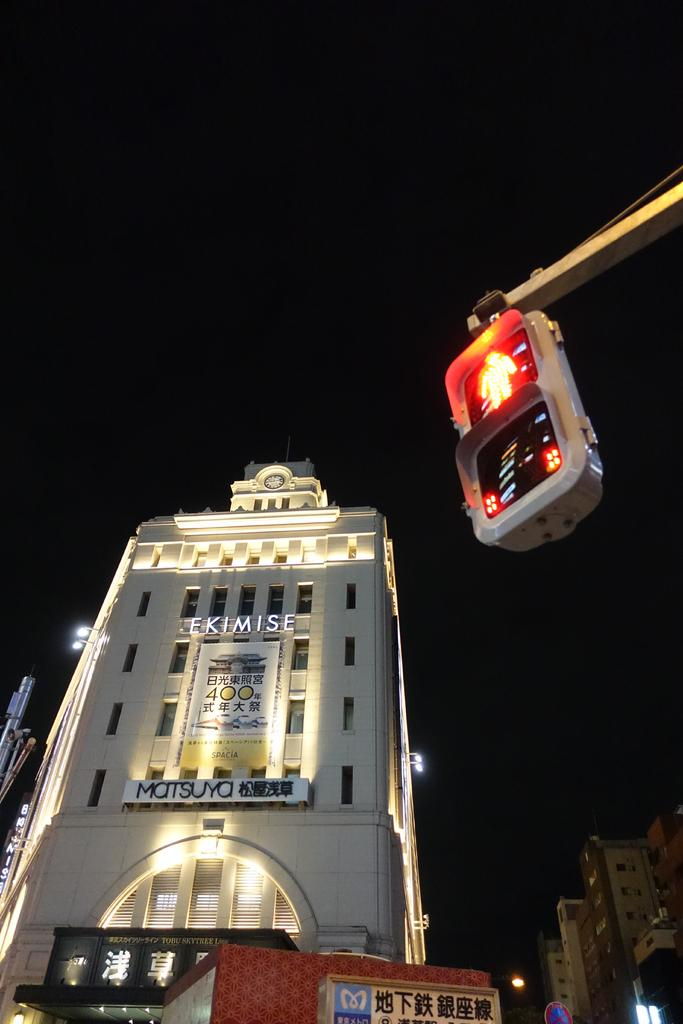Provide a one-sentence caption for the provided image. a huge white business with Chinese readings on them. 